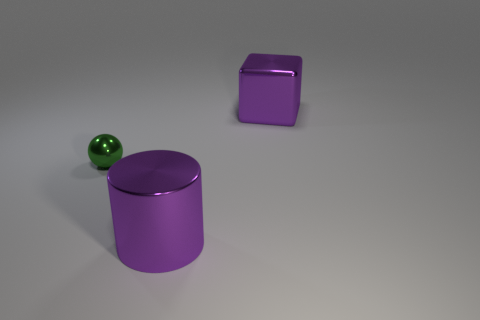There is a purple object that is the same size as the metal block; what shape is it?
Offer a terse response. Cylinder. Does the large shiny thing in front of the large shiny cube have the same color as the tiny object?
Keep it short and to the point. No. What number of things are big purple shiny cylinders that are right of the green metal ball or yellow rubber cylinders?
Provide a short and direct response. 1. Are there more purple metal cubes that are in front of the large purple metallic cylinder than purple metallic cylinders to the left of the metal sphere?
Give a very brief answer. No. Are the sphere and the cube made of the same material?
Your answer should be compact. Yes. There is a object that is in front of the purple shiny block and behind the purple cylinder; what shape is it?
Your answer should be compact. Sphere. The tiny green thing that is made of the same material as the big block is what shape?
Your answer should be compact. Sphere. Are there any big purple cylinders?
Your answer should be very brief. Yes. Is there a big block that is left of the purple shiny thing that is in front of the large purple cube?
Keep it short and to the point. No. Is the number of green metallic balls greater than the number of big purple things?
Ensure brevity in your answer.  No. 